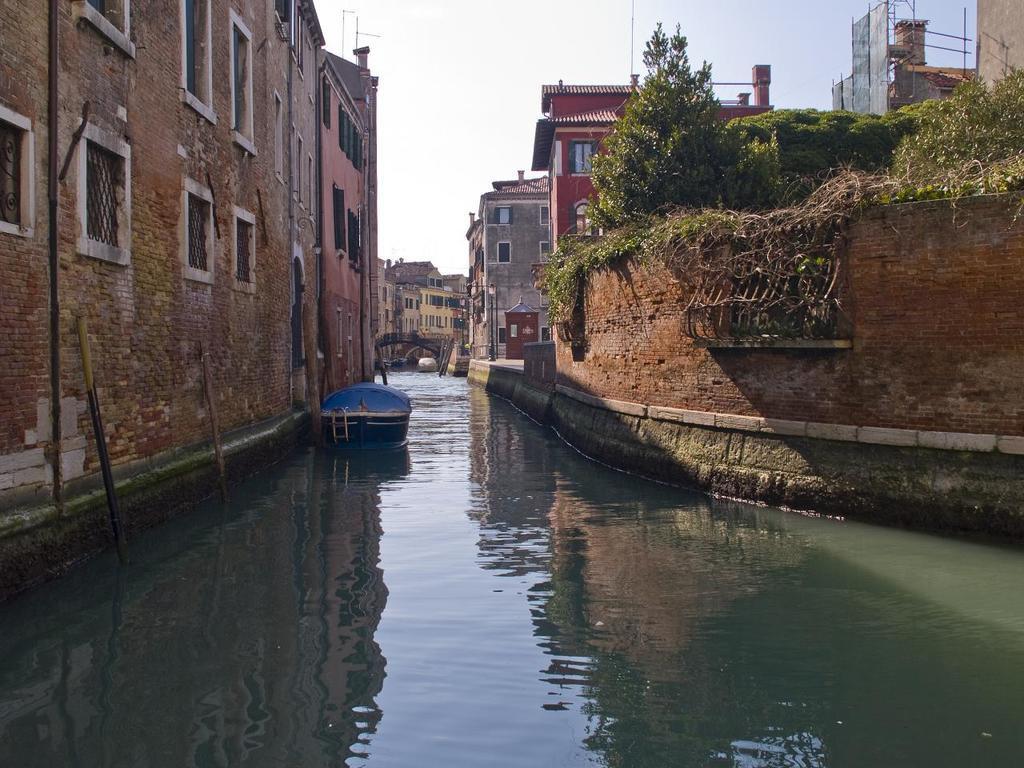Could you give a brief overview of what you see in this image? In this image on the left side and on the right side I can see buildings , between the building I can see the lake , o the lake I can see a boat and on the right side building at the top I can see trees and at the top I can see the sky. 